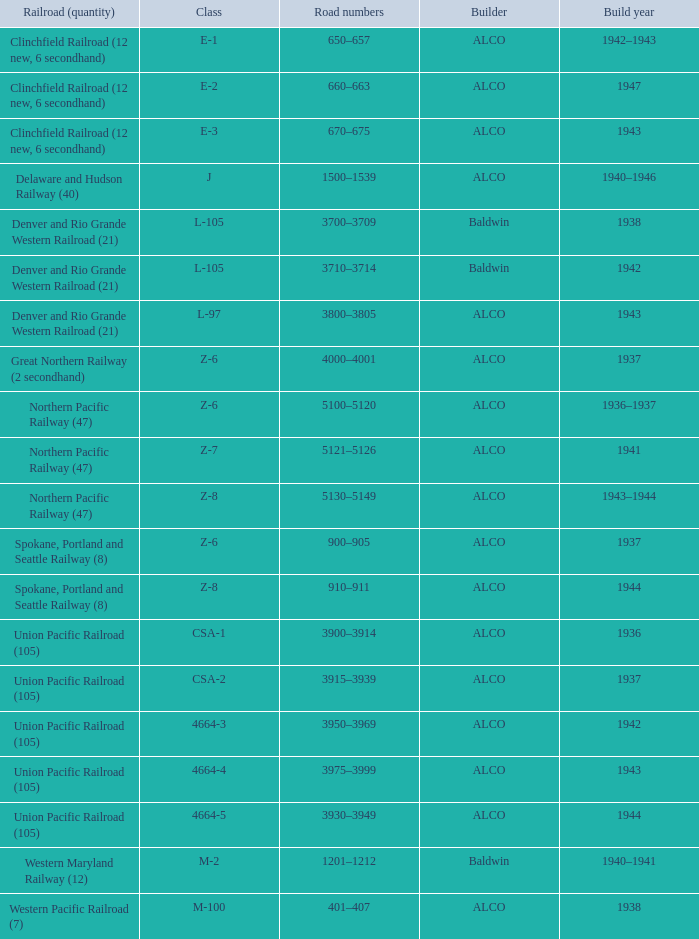What are the highway digits when the constructor is alco, the railway (amount) is union pacific railroad (105), and the category is csa-2? 3915–3939. 